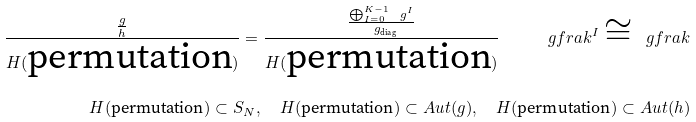<formula> <loc_0><loc_0><loc_500><loc_500>\frac { \frac { g } { h } } { H ( \text {permutation} ) } = \frac { \frac { \bigoplus _ { I = 0 } ^ { K - 1 } \ g ^ { I } } { \ g _ { \text {diag} } } } { H ( \text {permutation} ) } \, \quad \ g f r a k ^ { I } \cong \ g f r a k \\ H ( \text {permutation} ) \subset S _ { N } , \quad H ( \text {permutation} ) \subset A u t ( g ) , \quad H ( \text {permutation} ) \subset A u t ( h )</formula> 